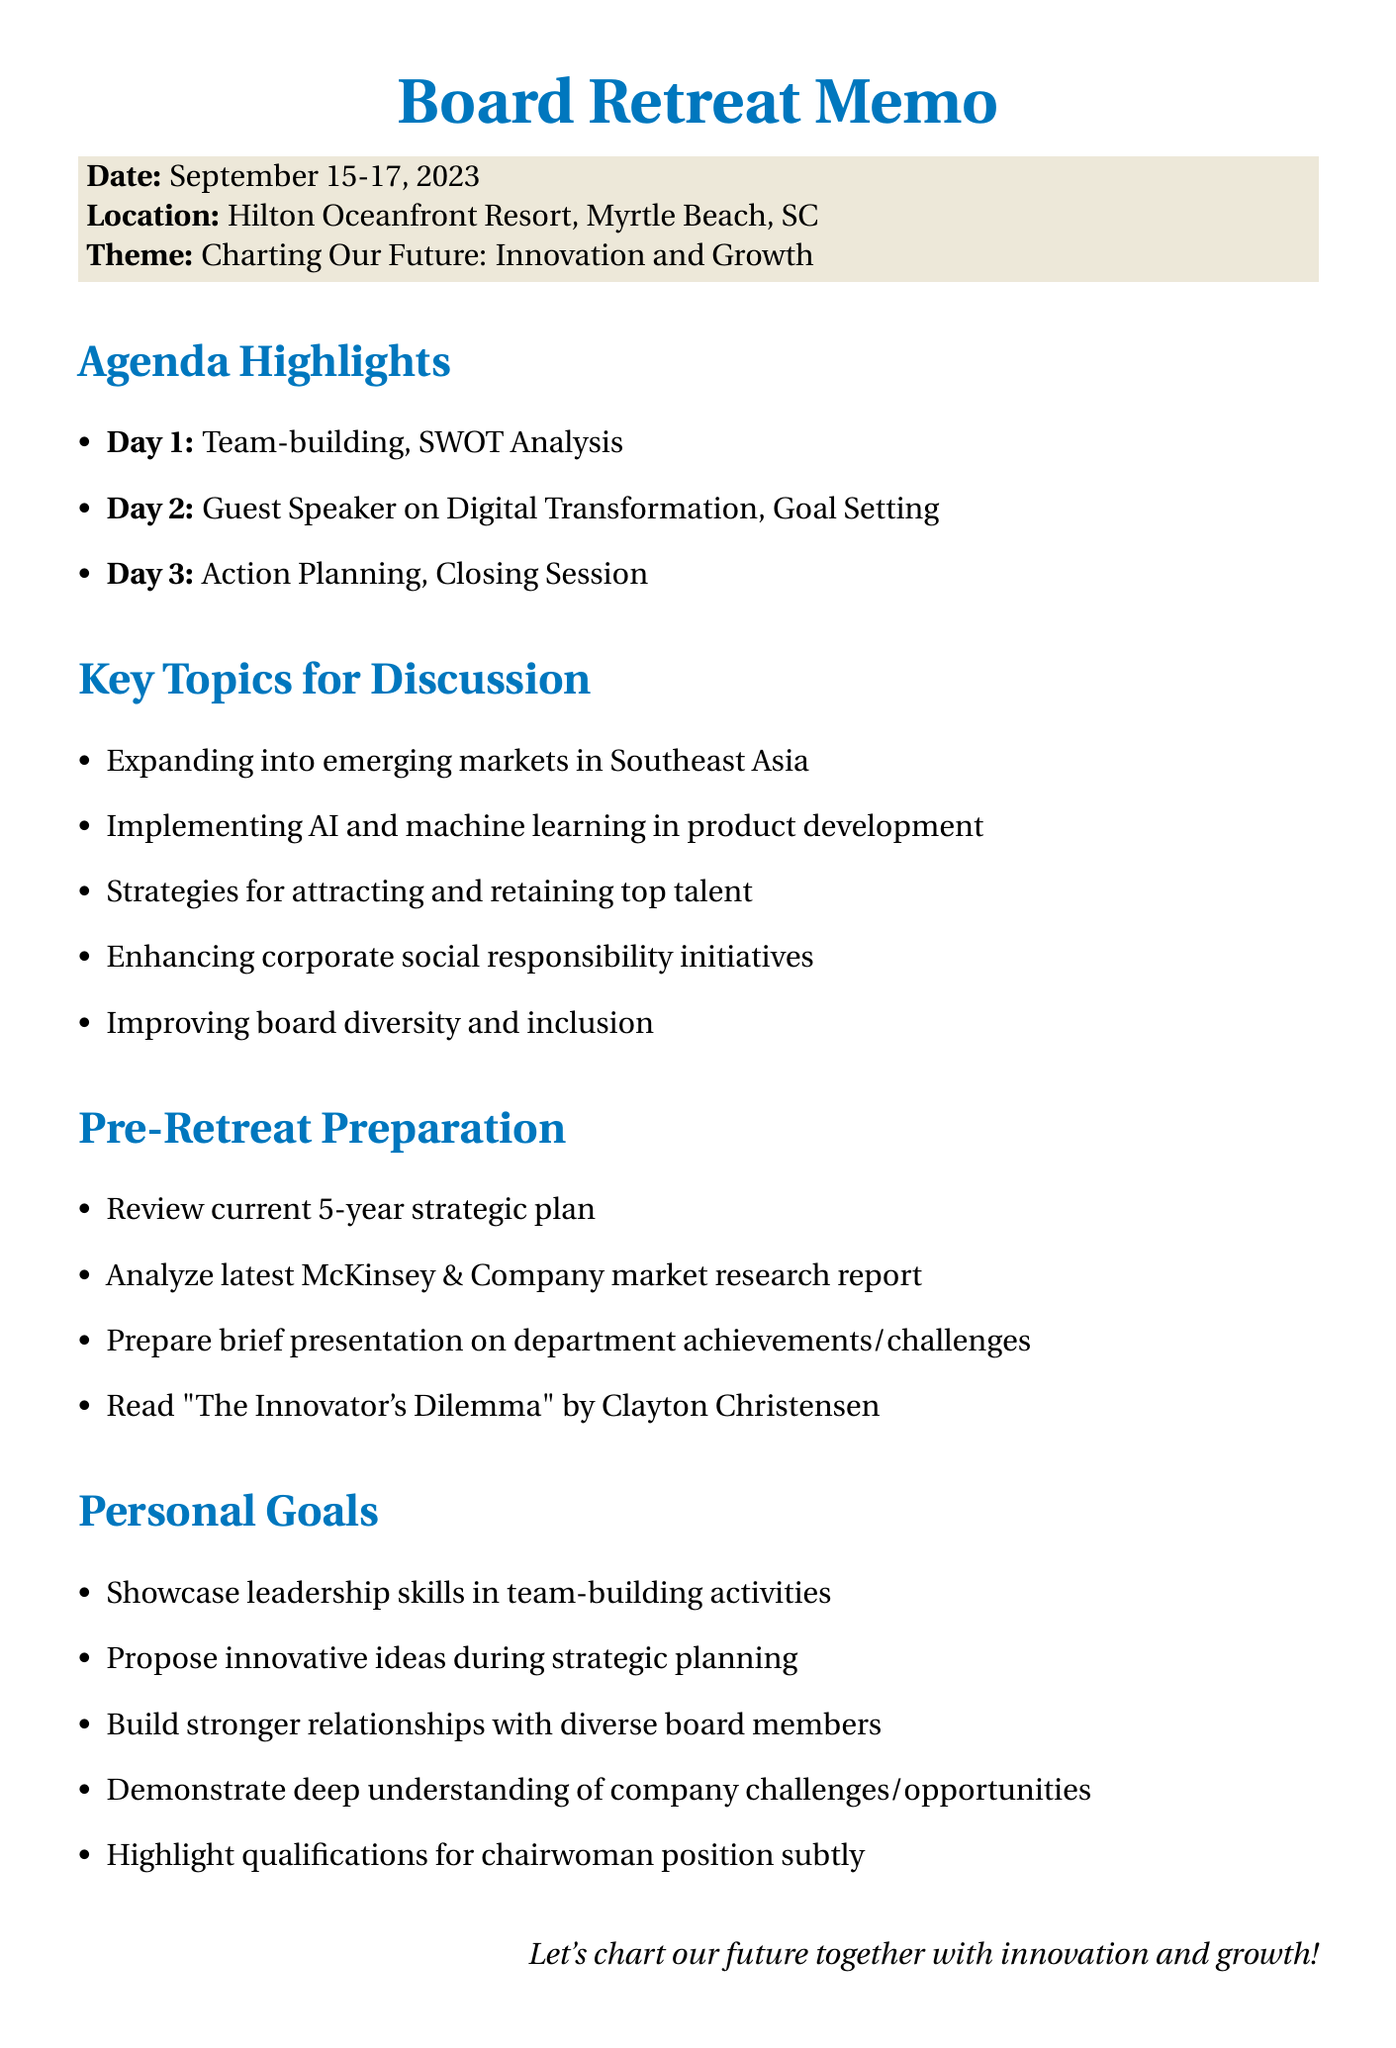What are the dates of the board retreat? The dates of the board retreat are explicitly mentioned as September 15-17, 2023.
Answer: September 15-17, 2023 Where is the board retreat taking place? The location of the board retreat is specified in the memo as Hilton Oceanfront Resort, Myrtle Beach, SC.
Answer: Hilton Oceanfront Resort, Myrtle Beach, SC What is the theme of the retreat? The theme for the retreat is highlighted in the memo as Charting Our Future: Innovation and Growth.
Answer: Charting Our Future: Innovation and Growth What is the name of the guest speaker? The memo lists Sarah Johnson as the guest speaker during the retreat.
Answer: Sarah Johnson How many strategic planning sessions are included in the agenda? The agenda includes three strategic planning sessions across the three days of the retreat.
Answer: Three What activity is scheduled for Day 1 at 10:45 AM? The activity listed for Day 1 at that time is a team-building exercise titled 'Build a Bridge'.
Answer: Team-building Exercise: 'Build a Bridge' Which book is recommended for pre-retreat preparation? The memorandum suggests reading 'The Innovator's Dilemma' by Clayton Christensen for preparation.
Answer: 'The Innovator's Dilemma' What is one personal goal mentioned for board members during the retreat? The personal goals section details several objectives, including to showcase leadership skills during team-building activities.
Answer: Showcase leadership skills during team-building activities What is the focus of the strategic planning session on Day 3? The focus of the strategic planning session on Day 3 is identified as Action Planning.
Answer: Action Planning 